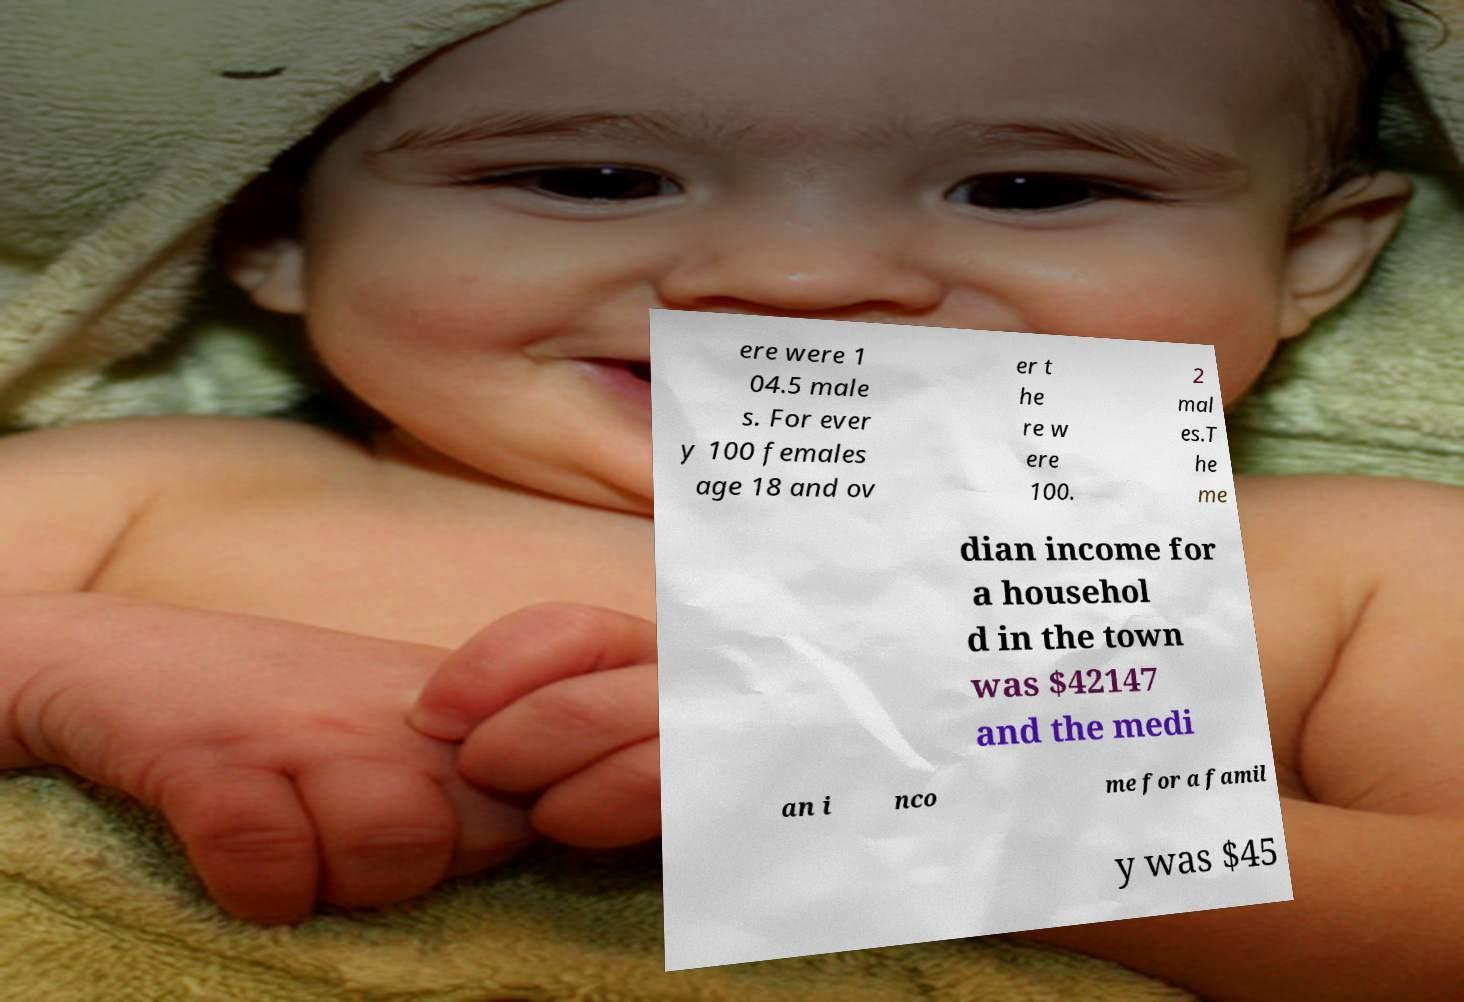Can you accurately transcribe the text from the provided image for me? ere were 1 04.5 male s. For ever y 100 females age 18 and ov er t he re w ere 100. 2 mal es.T he me dian income for a househol d in the town was $42147 and the medi an i nco me for a famil y was $45 